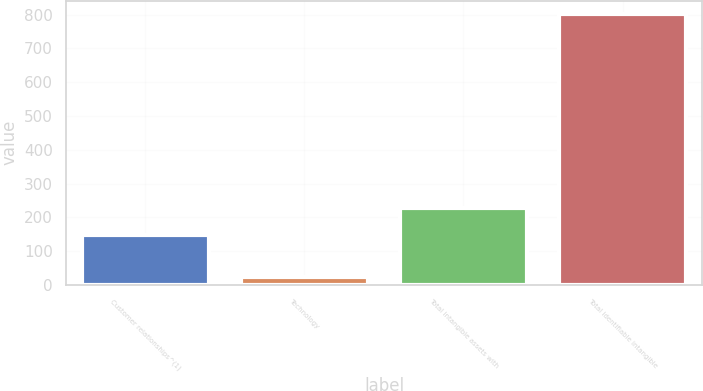Convert chart to OTSL. <chart><loc_0><loc_0><loc_500><loc_500><bar_chart><fcel>Customer relationships^(1)<fcel>Technology<fcel>Total intangible assets with<fcel>Total identifiable intangible<nl><fcel>148.9<fcel>22.2<fcel>226.81<fcel>801.3<nl></chart> 